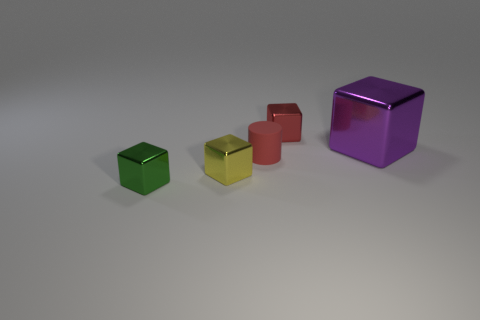Is there any other thing that is made of the same material as the tiny red cylinder?
Make the answer very short. No. Are there an equal number of tiny yellow blocks that are to the right of the purple metal thing and small yellow things?
Provide a succinct answer. No. There is a red metallic block; is it the same size as the metallic object to the right of the red metal block?
Your answer should be compact. No. How many large purple objects are the same material as the big cube?
Provide a short and direct response. 0. Is the size of the red metal thing the same as the matte object?
Your response must be concise. Yes. Is there any other thing of the same color as the small rubber cylinder?
Ensure brevity in your answer.  Yes. There is a thing that is both in front of the purple cube and behind the yellow metal block; what shape is it?
Provide a succinct answer. Cylinder. How big is the red thing that is on the right side of the matte object?
Your answer should be very brief. Small. There is a thing that is to the left of the yellow thing that is in front of the tiny matte cylinder; how many tiny green objects are behind it?
Keep it short and to the point. 0. There is a tiny green thing; are there any tiny green shiny blocks in front of it?
Keep it short and to the point. No. 